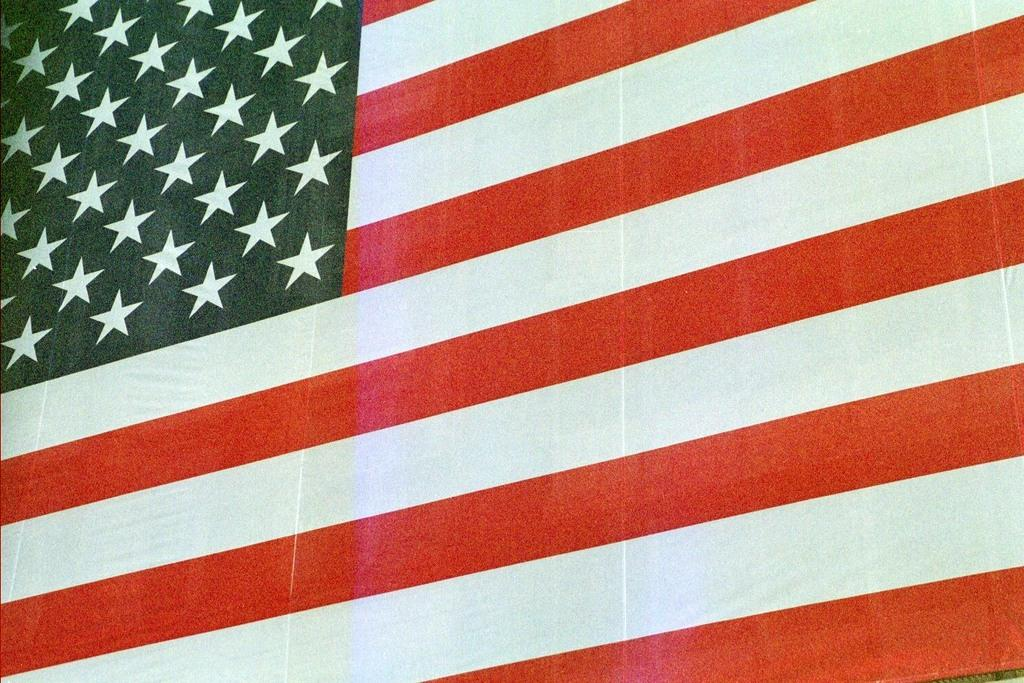What is the main object visible in the image? There is a flag in the image. What type of sand can be seen on the stage during the peace rally in the image? There is no sand, stage, or peace rally present in the image; it only features a flag. 